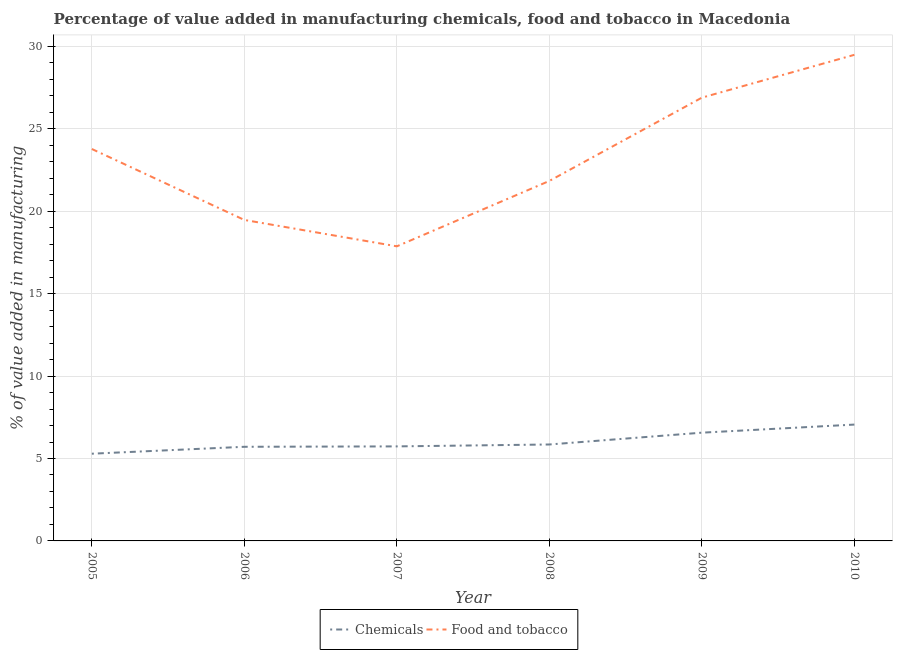How many different coloured lines are there?
Offer a terse response. 2. What is the value added by manufacturing food and tobacco in 2008?
Give a very brief answer. 21.84. Across all years, what is the maximum value added by manufacturing food and tobacco?
Ensure brevity in your answer.  29.49. Across all years, what is the minimum value added by  manufacturing chemicals?
Offer a terse response. 5.29. In which year was the value added by  manufacturing chemicals maximum?
Ensure brevity in your answer.  2010. What is the total value added by manufacturing food and tobacco in the graph?
Make the answer very short. 139.34. What is the difference between the value added by manufacturing food and tobacco in 2009 and that in 2010?
Give a very brief answer. -2.6. What is the difference between the value added by  manufacturing chemicals in 2009 and the value added by manufacturing food and tobacco in 2005?
Your answer should be compact. -17.21. What is the average value added by  manufacturing chemicals per year?
Provide a short and direct response. 6.04. In the year 2005, what is the difference between the value added by manufacturing food and tobacco and value added by  manufacturing chemicals?
Your answer should be very brief. 18.48. What is the ratio of the value added by manufacturing food and tobacco in 2005 to that in 2010?
Your answer should be compact. 0.81. Is the difference between the value added by manufacturing food and tobacco in 2006 and 2007 greater than the difference between the value added by  manufacturing chemicals in 2006 and 2007?
Keep it short and to the point. Yes. What is the difference between the highest and the second highest value added by manufacturing food and tobacco?
Your answer should be very brief. 2.6. What is the difference between the highest and the lowest value added by manufacturing food and tobacco?
Your response must be concise. 11.62. In how many years, is the value added by manufacturing food and tobacco greater than the average value added by manufacturing food and tobacco taken over all years?
Your response must be concise. 3. Is the sum of the value added by manufacturing food and tobacco in 2005 and 2006 greater than the maximum value added by  manufacturing chemicals across all years?
Your answer should be compact. Yes. Does the value added by manufacturing food and tobacco monotonically increase over the years?
Your response must be concise. No. Is the value added by manufacturing food and tobacco strictly greater than the value added by  manufacturing chemicals over the years?
Your response must be concise. Yes. How many years are there in the graph?
Ensure brevity in your answer.  6. Does the graph contain any zero values?
Keep it short and to the point. No. Does the graph contain grids?
Your answer should be compact. Yes. How are the legend labels stacked?
Offer a very short reply. Horizontal. What is the title of the graph?
Ensure brevity in your answer.  Percentage of value added in manufacturing chemicals, food and tobacco in Macedonia. What is the label or title of the X-axis?
Provide a succinct answer. Year. What is the label or title of the Y-axis?
Keep it short and to the point. % of value added in manufacturing. What is the % of value added in manufacturing of Chemicals in 2005?
Offer a very short reply. 5.29. What is the % of value added in manufacturing of Food and tobacco in 2005?
Provide a succinct answer. 23.78. What is the % of value added in manufacturing in Chemicals in 2006?
Keep it short and to the point. 5.71. What is the % of value added in manufacturing in Food and tobacco in 2006?
Your answer should be compact. 19.47. What is the % of value added in manufacturing in Chemicals in 2007?
Offer a terse response. 5.73. What is the % of value added in manufacturing in Food and tobacco in 2007?
Offer a terse response. 17.87. What is the % of value added in manufacturing of Chemicals in 2008?
Your response must be concise. 5.85. What is the % of value added in manufacturing in Food and tobacco in 2008?
Provide a succinct answer. 21.84. What is the % of value added in manufacturing in Chemicals in 2009?
Ensure brevity in your answer.  6.57. What is the % of value added in manufacturing in Food and tobacco in 2009?
Offer a terse response. 26.89. What is the % of value added in manufacturing of Chemicals in 2010?
Keep it short and to the point. 7.06. What is the % of value added in manufacturing in Food and tobacco in 2010?
Keep it short and to the point. 29.49. Across all years, what is the maximum % of value added in manufacturing in Chemicals?
Provide a succinct answer. 7.06. Across all years, what is the maximum % of value added in manufacturing in Food and tobacco?
Your answer should be compact. 29.49. Across all years, what is the minimum % of value added in manufacturing of Chemicals?
Ensure brevity in your answer.  5.29. Across all years, what is the minimum % of value added in manufacturing in Food and tobacco?
Make the answer very short. 17.87. What is the total % of value added in manufacturing of Chemicals in the graph?
Give a very brief answer. 36.21. What is the total % of value added in manufacturing in Food and tobacco in the graph?
Offer a terse response. 139.34. What is the difference between the % of value added in manufacturing of Chemicals in 2005 and that in 2006?
Make the answer very short. -0.42. What is the difference between the % of value added in manufacturing of Food and tobacco in 2005 and that in 2006?
Give a very brief answer. 4.3. What is the difference between the % of value added in manufacturing of Chemicals in 2005 and that in 2007?
Offer a very short reply. -0.44. What is the difference between the % of value added in manufacturing in Food and tobacco in 2005 and that in 2007?
Keep it short and to the point. 5.9. What is the difference between the % of value added in manufacturing in Chemicals in 2005 and that in 2008?
Give a very brief answer. -0.56. What is the difference between the % of value added in manufacturing of Food and tobacco in 2005 and that in 2008?
Provide a short and direct response. 1.94. What is the difference between the % of value added in manufacturing in Chemicals in 2005 and that in 2009?
Keep it short and to the point. -1.28. What is the difference between the % of value added in manufacturing of Food and tobacco in 2005 and that in 2009?
Offer a very short reply. -3.11. What is the difference between the % of value added in manufacturing of Chemicals in 2005 and that in 2010?
Offer a very short reply. -1.77. What is the difference between the % of value added in manufacturing in Food and tobacco in 2005 and that in 2010?
Provide a succinct answer. -5.71. What is the difference between the % of value added in manufacturing of Chemicals in 2006 and that in 2007?
Offer a terse response. -0.02. What is the difference between the % of value added in manufacturing of Food and tobacco in 2006 and that in 2007?
Provide a succinct answer. 1.6. What is the difference between the % of value added in manufacturing of Chemicals in 2006 and that in 2008?
Offer a very short reply. -0.14. What is the difference between the % of value added in manufacturing in Food and tobacco in 2006 and that in 2008?
Your answer should be compact. -2.37. What is the difference between the % of value added in manufacturing of Chemicals in 2006 and that in 2009?
Ensure brevity in your answer.  -0.86. What is the difference between the % of value added in manufacturing in Food and tobacco in 2006 and that in 2009?
Provide a succinct answer. -7.42. What is the difference between the % of value added in manufacturing of Chemicals in 2006 and that in 2010?
Offer a terse response. -1.35. What is the difference between the % of value added in manufacturing of Food and tobacco in 2006 and that in 2010?
Offer a terse response. -10.02. What is the difference between the % of value added in manufacturing in Chemicals in 2007 and that in 2008?
Your answer should be very brief. -0.12. What is the difference between the % of value added in manufacturing in Food and tobacco in 2007 and that in 2008?
Offer a very short reply. -3.97. What is the difference between the % of value added in manufacturing in Chemicals in 2007 and that in 2009?
Make the answer very short. -0.83. What is the difference between the % of value added in manufacturing of Food and tobacco in 2007 and that in 2009?
Offer a very short reply. -9.02. What is the difference between the % of value added in manufacturing in Chemicals in 2007 and that in 2010?
Keep it short and to the point. -1.32. What is the difference between the % of value added in manufacturing in Food and tobacco in 2007 and that in 2010?
Offer a terse response. -11.62. What is the difference between the % of value added in manufacturing of Chemicals in 2008 and that in 2009?
Provide a succinct answer. -0.72. What is the difference between the % of value added in manufacturing in Food and tobacco in 2008 and that in 2009?
Offer a very short reply. -5.05. What is the difference between the % of value added in manufacturing in Chemicals in 2008 and that in 2010?
Offer a very short reply. -1.21. What is the difference between the % of value added in manufacturing of Food and tobacco in 2008 and that in 2010?
Your answer should be compact. -7.65. What is the difference between the % of value added in manufacturing in Chemicals in 2009 and that in 2010?
Offer a terse response. -0.49. What is the difference between the % of value added in manufacturing in Food and tobacco in 2009 and that in 2010?
Ensure brevity in your answer.  -2.6. What is the difference between the % of value added in manufacturing of Chemicals in 2005 and the % of value added in manufacturing of Food and tobacco in 2006?
Provide a succinct answer. -14.18. What is the difference between the % of value added in manufacturing in Chemicals in 2005 and the % of value added in manufacturing in Food and tobacco in 2007?
Your answer should be compact. -12.58. What is the difference between the % of value added in manufacturing in Chemicals in 2005 and the % of value added in manufacturing in Food and tobacco in 2008?
Your answer should be very brief. -16.55. What is the difference between the % of value added in manufacturing of Chemicals in 2005 and the % of value added in manufacturing of Food and tobacco in 2009?
Your answer should be compact. -21.6. What is the difference between the % of value added in manufacturing of Chemicals in 2005 and the % of value added in manufacturing of Food and tobacco in 2010?
Offer a terse response. -24.2. What is the difference between the % of value added in manufacturing in Chemicals in 2006 and the % of value added in manufacturing in Food and tobacco in 2007?
Provide a succinct answer. -12.16. What is the difference between the % of value added in manufacturing of Chemicals in 2006 and the % of value added in manufacturing of Food and tobacco in 2008?
Ensure brevity in your answer.  -16.13. What is the difference between the % of value added in manufacturing of Chemicals in 2006 and the % of value added in manufacturing of Food and tobacco in 2009?
Provide a short and direct response. -21.18. What is the difference between the % of value added in manufacturing in Chemicals in 2006 and the % of value added in manufacturing in Food and tobacco in 2010?
Keep it short and to the point. -23.78. What is the difference between the % of value added in manufacturing of Chemicals in 2007 and the % of value added in manufacturing of Food and tobacco in 2008?
Give a very brief answer. -16.1. What is the difference between the % of value added in manufacturing in Chemicals in 2007 and the % of value added in manufacturing in Food and tobacco in 2009?
Offer a very short reply. -21.16. What is the difference between the % of value added in manufacturing of Chemicals in 2007 and the % of value added in manufacturing of Food and tobacco in 2010?
Provide a succinct answer. -23.75. What is the difference between the % of value added in manufacturing of Chemicals in 2008 and the % of value added in manufacturing of Food and tobacco in 2009?
Your answer should be compact. -21.04. What is the difference between the % of value added in manufacturing in Chemicals in 2008 and the % of value added in manufacturing in Food and tobacco in 2010?
Offer a terse response. -23.64. What is the difference between the % of value added in manufacturing in Chemicals in 2009 and the % of value added in manufacturing in Food and tobacco in 2010?
Your answer should be compact. -22.92. What is the average % of value added in manufacturing of Chemicals per year?
Your answer should be very brief. 6.04. What is the average % of value added in manufacturing in Food and tobacco per year?
Your answer should be very brief. 23.22. In the year 2005, what is the difference between the % of value added in manufacturing of Chemicals and % of value added in manufacturing of Food and tobacco?
Offer a very short reply. -18.48. In the year 2006, what is the difference between the % of value added in manufacturing in Chemicals and % of value added in manufacturing in Food and tobacco?
Provide a short and direct response. -13.76. In the year 2007, what is the difference between the % of value added in manufacturing in Chemicals and % of value added in manufacturing in Food and tobacco?
Offer a very short reply. -12.14. In the year 2008, what is the difference between the % of value added in manufacturing in Chemicals and % of value added in manufacturing in Food and tobacco?
Make the answer very short. -15.99. In the year 2009, what is the difference between the % of value added in manufacturing in Chemicals and % of value added in manufacturing in Food and tobacco?
Your response must be concise. -20.32. In the year 2010, what is the difference between the % of value added in manufacturing of Chemicals and % of value added in manufacturing of Food and tobacco?
Offer a very short reply. -22.43. What is the ratio of the % of value added in manufacturing in Chemicals in 2005 to that in 2006?
Your response must be concise. 0.93. What is the ratio of the % of value added in manufacturing in Food and tobacco in 2005 to that in 2006?
Your response must be concise. 1.22. What is the ratio of the % of value added in manufacturing in Chemicals in 2005 to that in 2007?
Ensure brevity in your answer.  0.92. What is the ratio of the % of value added in manufacturing of Food and tobacco in 2005 to that in 2007?
Your answer should be very brief. 1.33. What is the ratio of the % of value added in manufacturing of Chemicals in 2005 to that in 2008?
Your answer should be compact. 0.9. What is the ratio of the % of value added in manufacturing of Food and tobacco in 2005 to that in 2008?
Provide a short and direct response. 1.09. What is the ratio of the % of value added in manufacturing in Chemicals in 2005 to that in 2009?
Your answer should be very brief. 0.81. What is the ratio of the % of value added in manufacturing of Food and tobacco in 2005 to that in 2009?
Provide a short and direct response. 0.88. What is the ratio of the % of value added in manufacturing of Chemicals in 2005 to that in 2010?
Make the answer very short. 0.75. What is the ratio of the % of value added in manufacturing of Food and tobacco in 2005 to that in 2010?
Your answer should be very brief. 0.81. What is the ratio of the % of value added in manufacturing of Chemicals in 2006 to that in 2007?
Make the answer very short. 1. What is the ratio of the % of value added in manufacturing of Food and tobacco in 2006 to that in 2007?
Ensure brevity in your answer.  1.09. What is the ratio of the % of value added in manufacturing in Food and tobacco in 2006 to that in 2008?
Make the answer very short. 0.89. What is the ratio of the % of value added in manufacturing of Chemicals in 2006 to that in 2009?
Provide a short and direct response. 0.87. What is the ratio of the % of value added in manufacturing of Food and tobacco in 2006 to that in 2009?
Offer a terse response. 0.72. What is the ratio of the % of value added in manufacturing of Chemicals in 2006 to that in 2010?
Offer a terse response. 0.81. What is the ratio of the % of value added in manufacturing in Food and tobacco in 2006 to that in 2010?
Provide a succinct answer. 0.66. What is the ratio of the % of value added in manufacturing of Chemicals in 2007 to that in 2008?
Provide a succinct answer. 0.98. What is the ratio of the % of value added in manufacturing of Food and tobacco in 2007 to that in 2008?
Your answer should be compact. 0.82. What is the ratio of the % of value added in manufacturing in Chemicals in 2007 to that in 2009?
Keep it short and to the point. 0.87. What is the ratio of the % of value added in manufacturing in Food and tobacco in 2007 to that in 2009?
Offer a terse response. 0.66. What is the ratio of the % of value added in manufacturing in Chemicals in 2007 to that in 2010?
Provide a short and direct response. 0.81. What is the ratio of the % of value added in manufacturing in Food and tobacco in 2007 to that in 2010?
Keep it short and to the point. 0.61. What is the ratio of the % of value added in manufacturing of Chemicals in 2008 to that in 2009?
Keep it short and to the point. 0.89. What is the ratio of the % of value added in manufacturing of Food and tobacco in 2008 to that in 2009?
Ensure brevity in your answer.  0.81. What is the ratio of the % of value added in manufacturing in Chemicals in 2008 to that in 2010?
Your answer should be very brief. 0.83. What is the ratio of the % of value added in manufacturing of Food and tobacco in 2008 to that in 2010?
Offer a very short reply. 0.74. What is the ratio of the % of value added in manufacturing of Chemicals in 2009 to that in 2010?
Your answer should be compact. 0.93. What is the ratio of the % of value added in manufacturing in Food and tobacco in 2009 to that in 2010?
Provide a succinct answer. 0.91. What is the difference between the highest and the second highest % of value added in manufacturing of Chemicals?
Offer a terse response. 0.49. What is the difference between the highest and the second highest % of value added in manufacturing in Food and tobacco?
Your answer should be very brief. 2.6. What is the difference between the highest and the lowest % of value added in manufacturing in Chemicals?
Keep it short and to the point. 1.77. What is the difference between the highest and the lowest % of value added in manufacturing in Food and tobacco?
Your response must be concise. 11.62. 